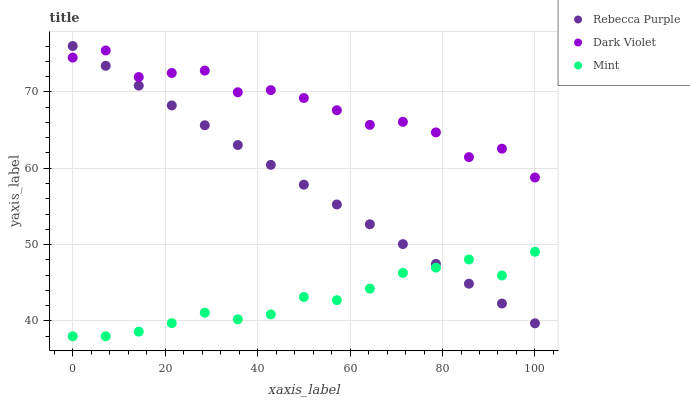Does Mint have the minimum area under the curve?
Answer yes or no. Yes. Does Dark Violet have the maximum area under the curve?
Answer yes or no. Yes. Does Rebecca Purple have the minimum area under the curve?
Answer yes or no. No. Does Rebecca Purple have the maximum area under the curve?
Answer yes or no. No. Is Rebecca Purple the smoothest?
Answer yes or no. Yes. Is Dark Violet the roughest?
Answer yes or no. Yes. Is Dark Violet the smoothest?
Answer yes or no. No. Is Rebecca Purple the roughest?
Answer yes or no. No. Does Mint have the lowest value?
Answer yes or no. Yes. Does Rebecca Purple have the lowest value?
Answer yes or no. No. Does Rebecca Purple have the highest value?
Answer yes or no. Yes. Does Dark Violet have the highest value?
Answer yes or no. No. Is Mint less than Dark Violet?
Answer yes or no. Yes. Is Dark Violet greater than Mint?
Answer yes or no. Yes. Does Dark Violet intersect Rebecca Purple?
Answer yes or no. Yes. Is Dark Violet less than Rebecca Purple?
Answer yes or no. No. Is Dark Violet greater than Rebecca Purple?
Answer yes or no. No. Does Mint intersect Dark Violet?
Answer yes or no. No. 